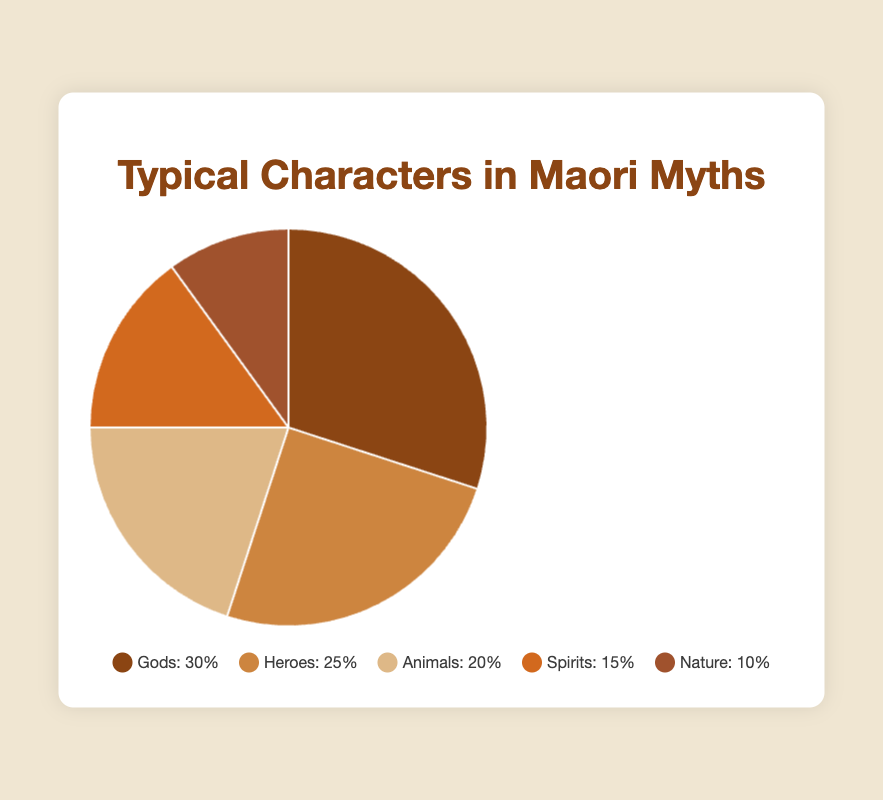What percentage of characters are either Animals or Nature? To find this, add the percentage of Animals (20%) to the percentage of Nature (10%). So, 20% + 10% = 30%
Answer: 30% Which character type has the smallest percentage representation in Maori myths? The character type with the smallest percentage is the one with the lowest number in the data. Nature has the lowest percentage at 10%
Answer: Nature How much more common are Gods than Spirits in Maori myths? Subtract the percentage of Spirits (15%) from the percentage of Gods (30%). Thus, 30% - 15% = 15%
Answer: 15% Which character type occupies the second largest segment of the pie chart? The type with the second largest segment has the second highest percentage. Heroes have the second largest percentage at 25%
Answer: Heroes If you combine the percentages of Heroes and Spirits, does it surpass the percentage of Gods? Add the percentage of Heroes (25%) and Spirits (15%). This equals 40%, which is greater than the percentage of Gods (30%)
Answer: Yes What is the visual color associated with the Nature segment? The Nature segment is represented by a darker tan or brown color
Answer: Darker tan or brown Are there more spirits or animals in Maori myths according to the data? Compare the percentages of Spirits (15%) and Animals (20%). Animals have a higher percentage
Answer: Animals What percentage of characters in Maori myths are neither Gods nor Heroes? Add the percentages of Animals (20%), Spirits (15%), and Nature (10%). Thus, 20% + 15% + 10% = 45%
Answer: 45% How does the color of the Heroes segment compare to the color of the Gods segment? The Heroes segment is a lighter brown (wheat color) compared to the darker brown (saddle brown) of the Gods segment
Answer: Lighter brown What is the total percentage of characters in Maori myths that are either Gods, Heroes, or Animals? Add the percentages of Gods (30%), Heroes (25%), and Animals (20%). Thus, 30% + 25% + 20% = 75%
Answer: 75% 